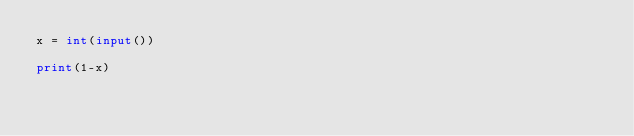<code> <loc_0><loc_0><loc_500><loc_500><_Python_>x = int(input())

print(1-x)
</code> 